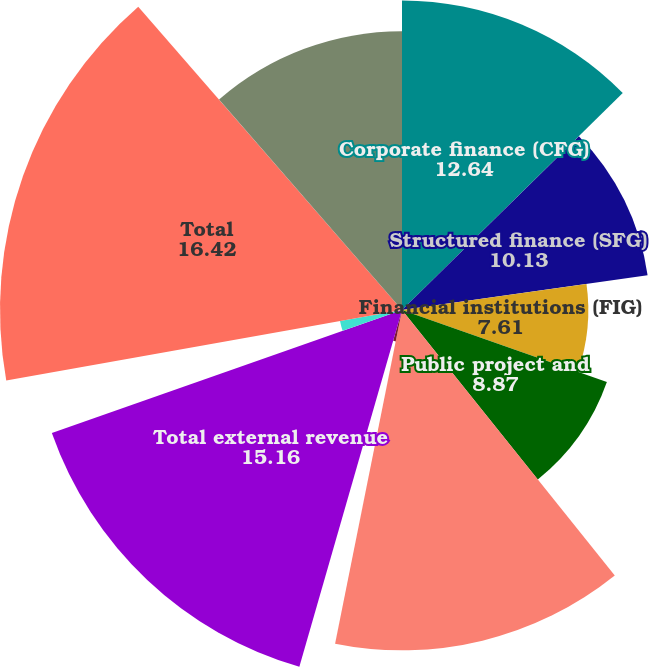Convert chart. <chart><loc_0><loc_0><loc_500><loc_500><pie_chart><fcel>Corporate finance (CFG)<fcel>Structured finance (SFG)<fcel>Financial institutions (FIG)<fcel>Public project and<fcel>Total ratings revenue<fcel>MIS Other<fcel>Total external revenue<fcel>Intersegment royalty<fcel>Total<fcel>Research data and analytics<nl><fcel>12.64%<fcel>10.13%<fcel>7.61%<fcel>8.87%<fcel>13.9%<fcel>1.31%<fcel>15.16%<fcel>2.57%<fcel>16.42%<fcel>11.39%<nl></chart> 